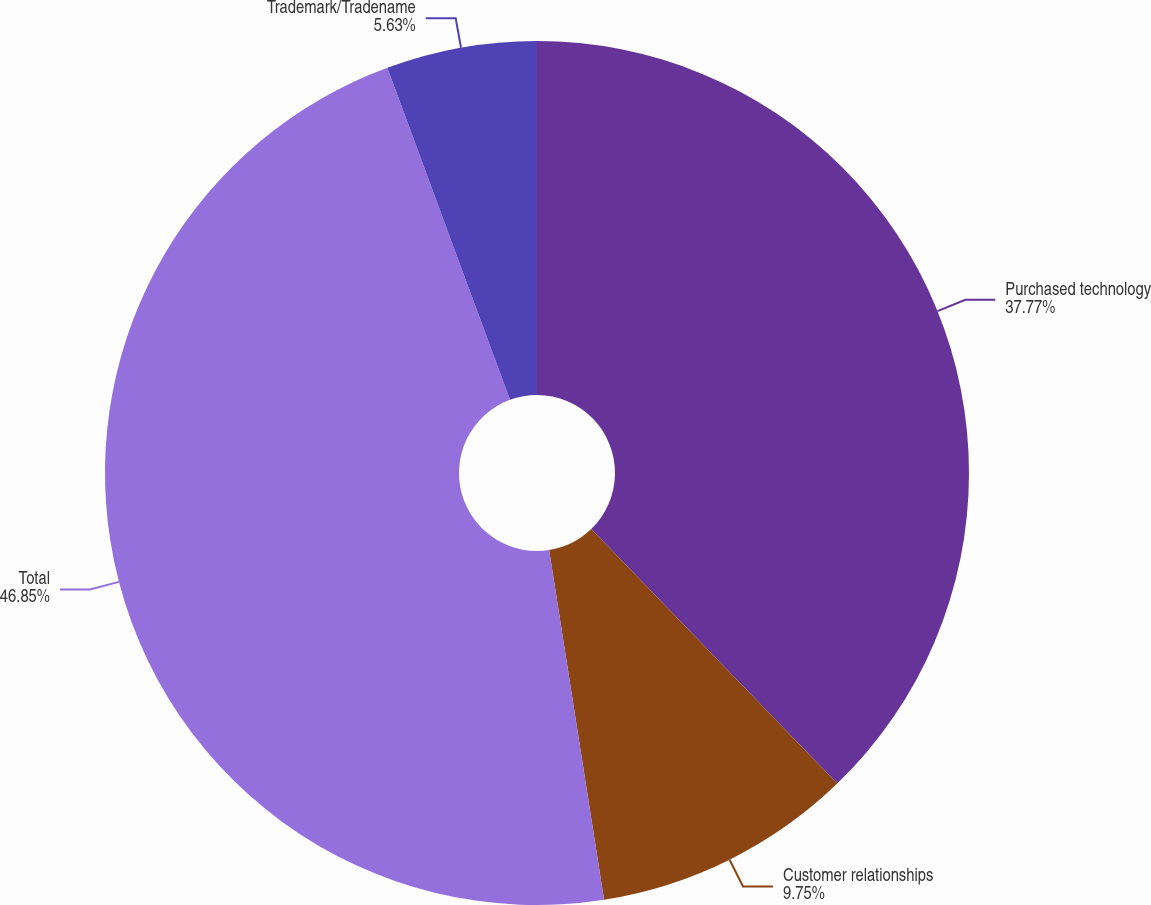Convert chart to OTSL. <chart><loc_0><loc_0><loc_500><loc_500><pie_chart><fcel>Purchased technology<fcel>Customer relationships<fcel>Total<fcel>Trademark/Tradename<nl><fcel>37.77%<fcel>9.75%<fcel>46.85%<fcel>5.63%<nl></chart> 